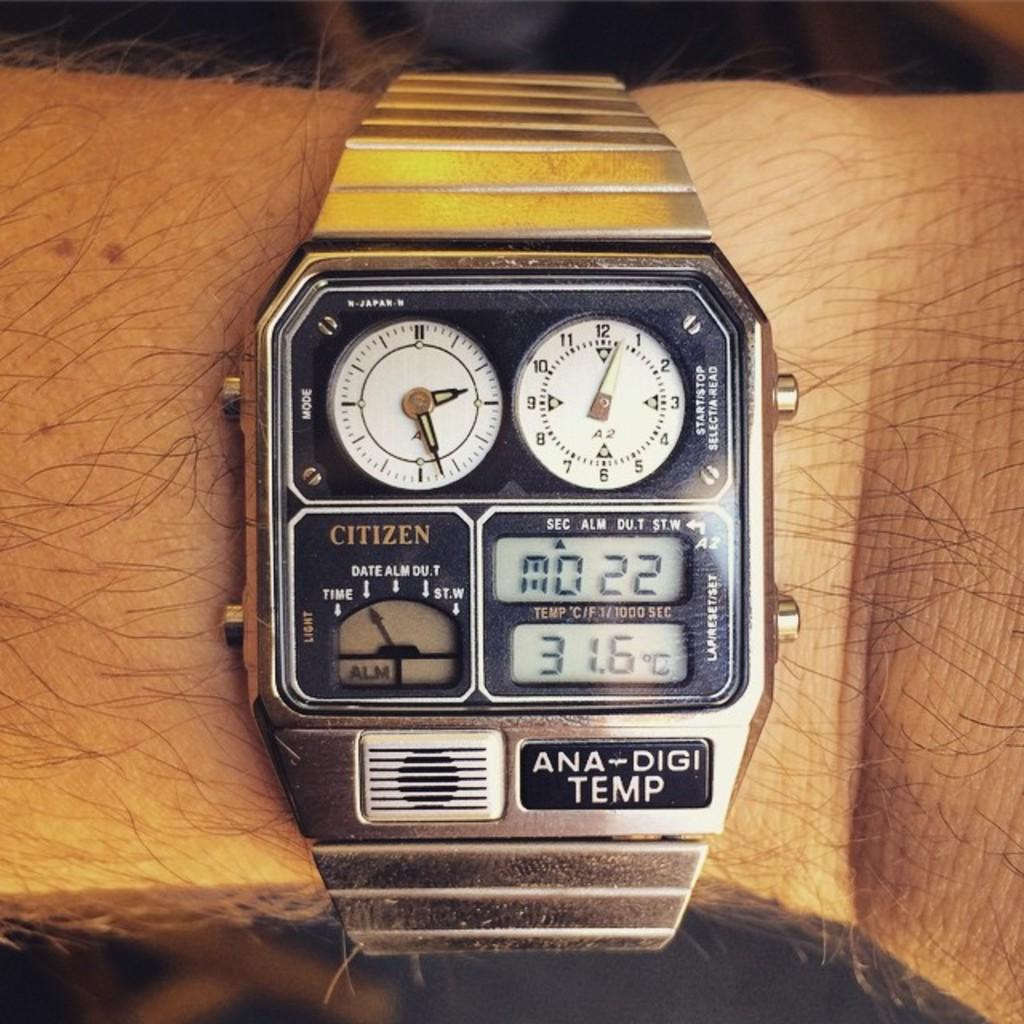<image>
Offer a succinct explanation of the picture presented. An ANA-DIGI Temp from Citizen shows the current temperature. 